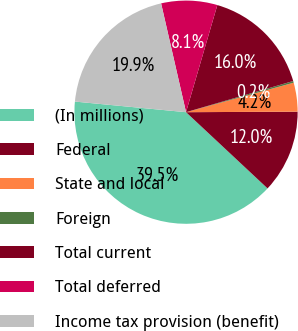Convert chart. <chart><loc_0><loc_0><loc_500><loc_500><pie_chart><fcel>(In millions)<fcel>Federal<fcel>State and local<fcel>Foreign<fcel>Total current<fcel>Total deferred<fcel>Income tax provision (benefit)<nl><fcel>39.55%<fcel>12.04%<fcel>4.18%<fcel>0.25%<fcel>15.97%<fcel>8.11%<fcel>19.9%<nl></chart> 